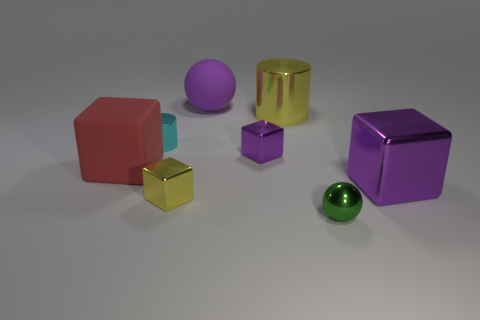Subtract all red blocks. How many blocks are left? 3 Subtract all big metallic blocks. How many blocks are left? 3 Subtract all cyan cubes. Subtract all yellow spheres. How many cubes are left? 4 Add 1 large purple matte spheres. How many objects exist? 9 Subtract all balls. How many objects are left? 6 Add 1 small cyan shiny cylinders. How many small cyan shiny cylinders are left? 2 Add 4 big purple things. How many big purple things exist? 6 Subtract 0 green cubes. How many objects are left? 8 Subtract all cubes. Subtract all small metallic things. How many objects are left? 0 